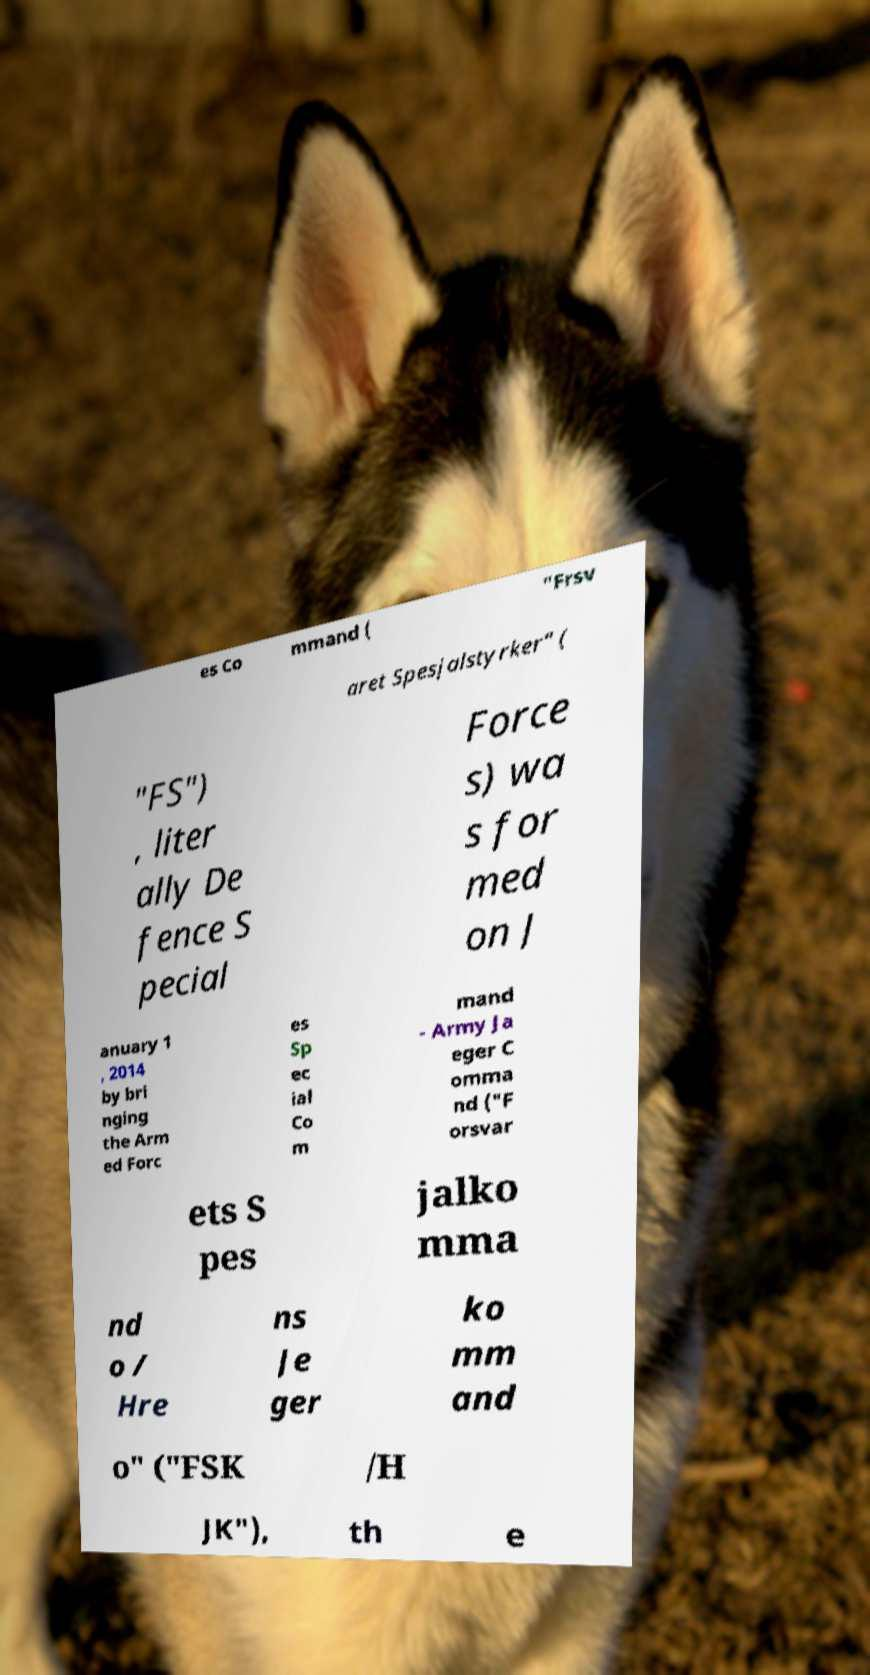Can you read and provide the text displayed in the image?This photo seems to have some interesting text. Can you extract and type it out for me? es Co mmand ( "Frsv aret Spesjalstyrker" ( "FS") , liter ally De fence S pecial Force s) wa s for med on J anuary 1 , 2014 by bri nging the Arm ed Forc es Sp ec ial Co m mand - Army Ja eger C omma nd ("F orsvar ets S pes jalko mma nd o / Hre ns Je ger ko mm and o" ("FSK /H JK"), th e 